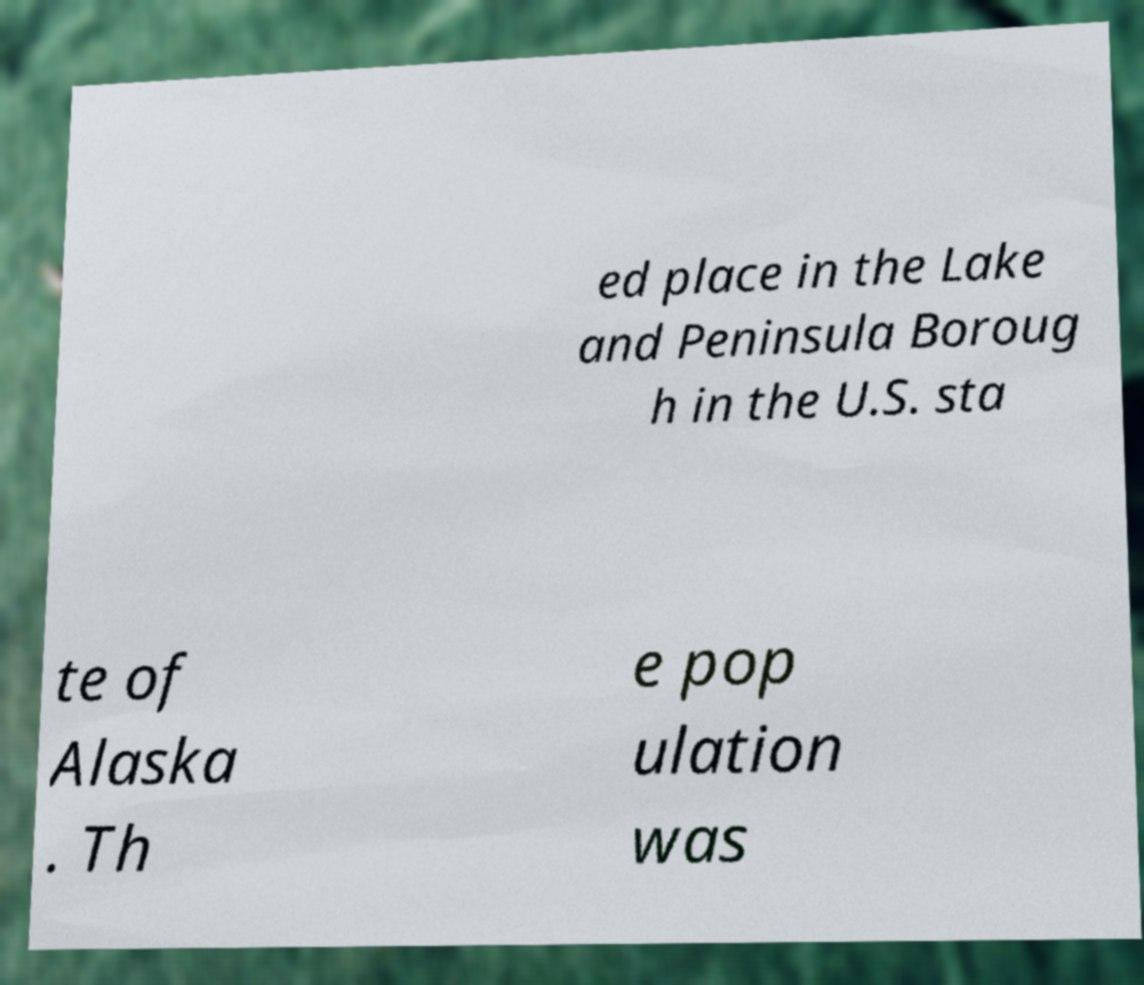For documentation purposes, I need the text within this image transcribed. Could you provide that? ed place in the Lake and Peninsula Boroug h in the U.S. sta te of Alaska . Th e pop ulation was 